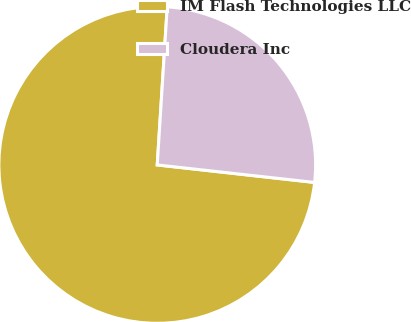<chart> <loc_0><loc_0><loc_500><loc_500><pie_chart><fcel>IM Flash Technologies LLC<fcel>Cloudera Inc<nl><fcel>74.24%<fcel>25.76%<nl></chart> 